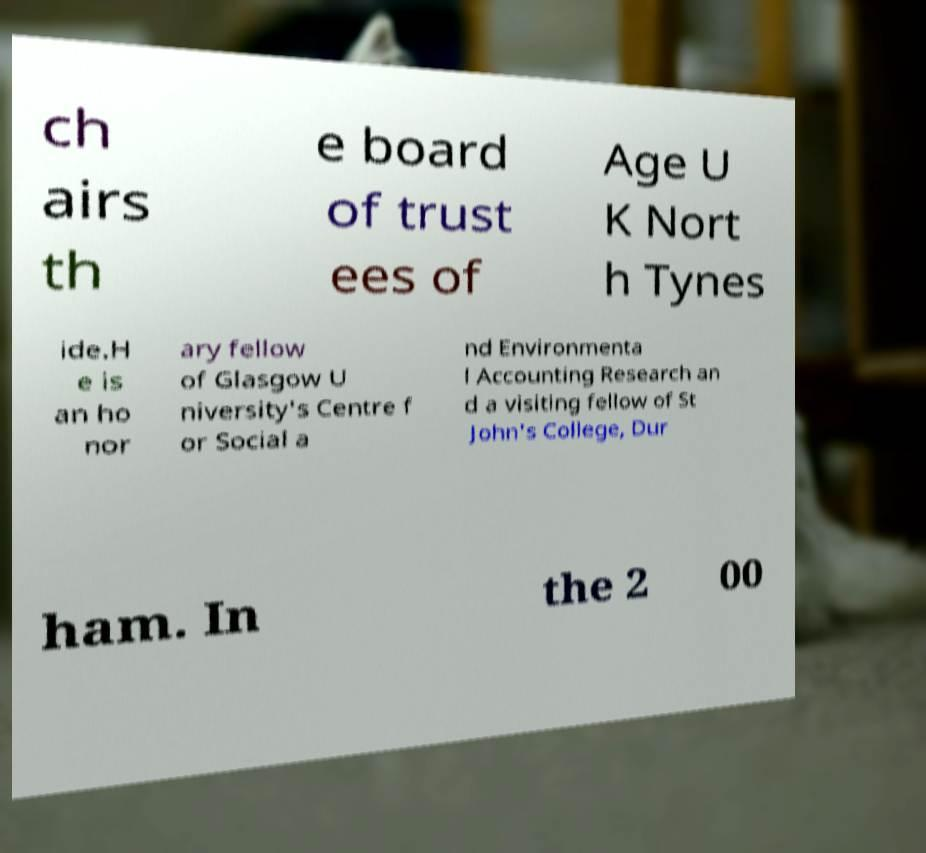For documentation purposes, I need the text within this image transcribed. Could you provide that? ch airs th e board of trust ees of Age U K Nort h Tynes ide.H e is an ho nor ary fellow of Glasgow U niversity's Centre f or Social a nd Environmenta l Accounting Research an d a visiting fellow of St John's College, Dur ham. In the 2 00 